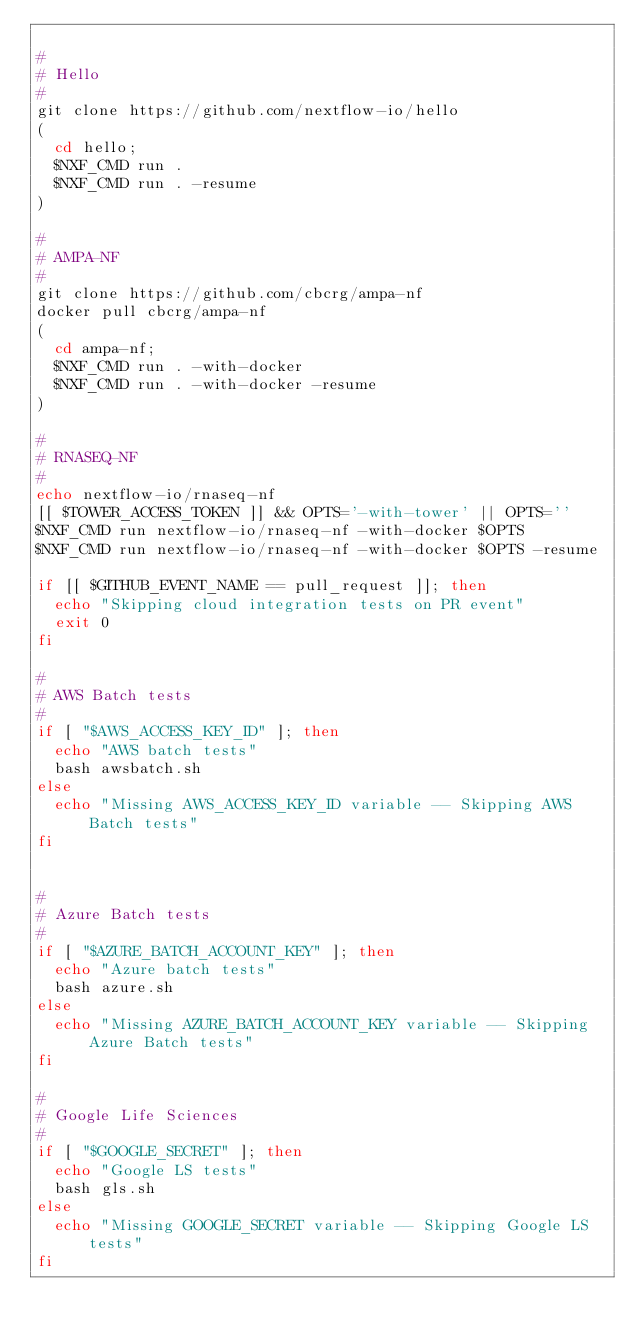Convert code to text. <code><loc_0><loc_0><loc_500><loc_500><_Bash_>
#
# Hello 
#
git clone https://github.com/nextflow-io/hello
( 
  cd hello; 
  $NXF_CMD run .
  $NXF_CMD run . -resume
)

#
# AMPA-NF
#
git clone https://github.com/cbcrg/ampa-nf
docker pull cbcrg/ampa-nf
(
  cd ampa-nf; 
  $NXF_CMD run . -with-docker 
  $NXF_CMD run . -with-docker -resume 
)

#
# RNASEQ-NF
#
echo nextflow-io/rnaseq-nf
[[ $TOWER_ACCESS_TOKEN ]] && OPTS='-with-tower' || OPTS=''
$NXF_CMD run nextflow-io/rnaseq-nf -with-docker $OPTS
$NXF_CMD run nextflow-io/rnaseq-nf -with-docker $OPTS -resume

if [[ $GITHUB_EVENT_NAME == pull_request ]]; then
  echo "Skipping cloud integration tests on PR event"
  exit 0
fi

#
# AWS Batch tests
#
if [ "$AWS_ACCESS_KEY_ID" ]; then
  echo "AWS batch tests"
  bash awsbatch.sh
else
  echo "Missing AWS_ACCESS_KEY_ID variable -- Skipping AWS Batch tests"
fi


#
# Azure Batch tests
#
if [ "$AZURE_BATCH_ACCOUNT_KEY" ]; then
  echo "Azure batch tests"
  bash azure.sh
else
  echo "Missing AZURE_BATCH_ACCOUNT_KEY variable -- Skipping Azure Batch tests"
fi

#
# Google Life Sciences
#
if [ "$GOOGLE_SECRET" ]; then
  echo "Google LS tests"
  bash gls.sh
else
  echo "Missing GOOGLE_SECRET variable -- Skipping Google LS tests"
fi

</code> 